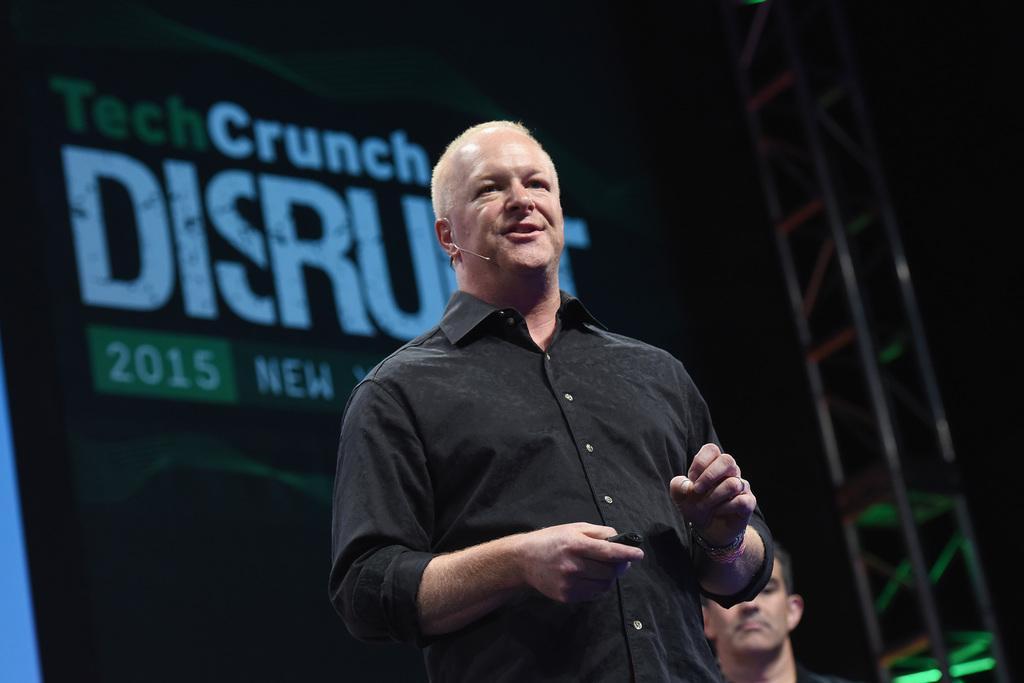Can you describe this image briefly? This person is highlighted in this picture. He wore black shirt and mic. Far there is a banner. Backside of this man another person is standing. 